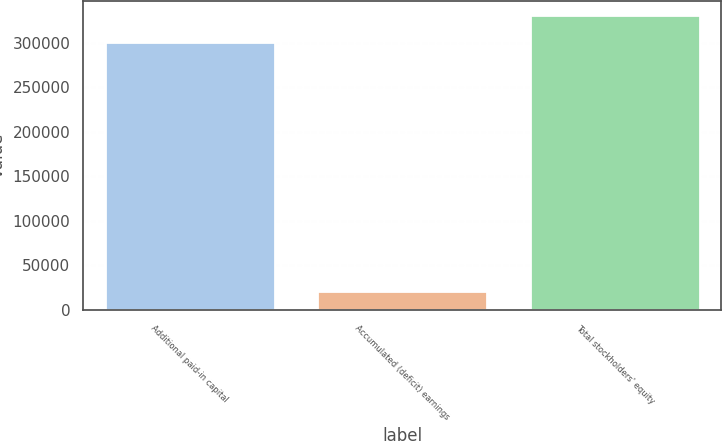<chart> <loc_0><loc_0><loc_500><loc_500><bar_chart><fcel>Additional paid-in capital<fcel>Accumulated (deficit) earnings<fcel>Total stockholders' equity<nl><fcel>300564<fcel>21441<fcel>330620<nl></chart> 